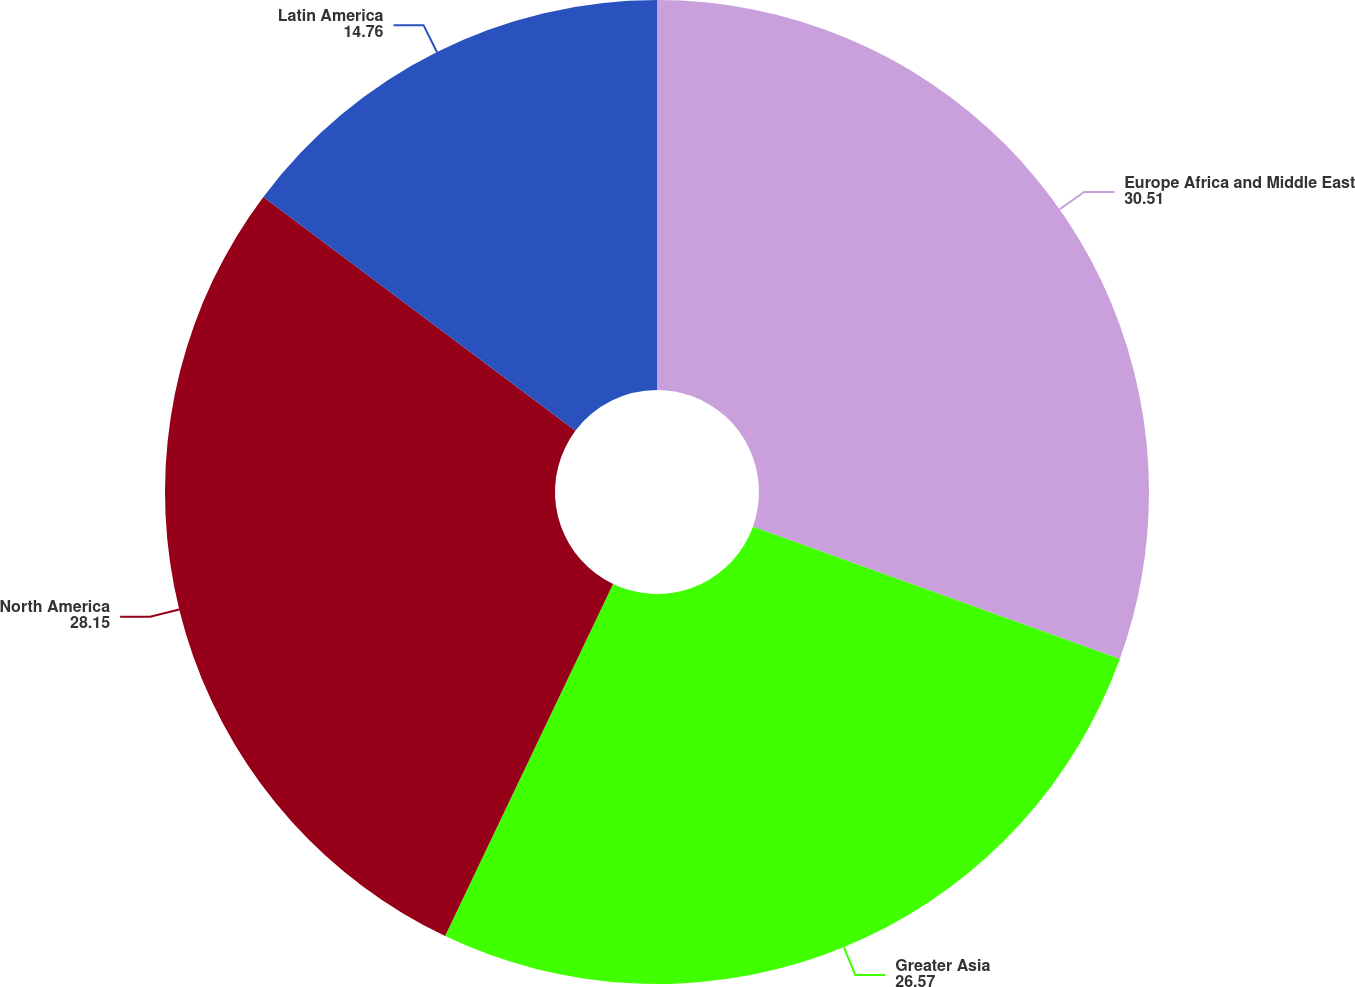Convert chart to OTSL. <chart><loc_0><loc_0><loc_500><loc_500><pie_chart><fcel>Europe Africa and Middle East<fcel>Greater Asia<fcel>North America<fcel>Latin America<nl><fcel>30.51%<fcel>26.57%<fcel>28.15%<fcel>14.76%<nl></chart> 